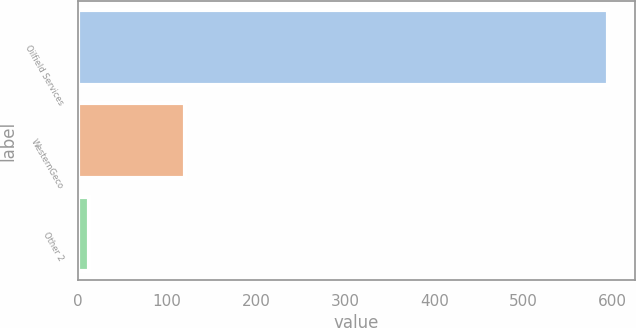<chart> <loc_0><loc_0><loc_500><loc_500><bar_chart><fcel>Oilfield Services<fcel>WesternGeco<fcel>Other 2<nl><fcel>595<fcel>120<fcel>13<nl></chart> 